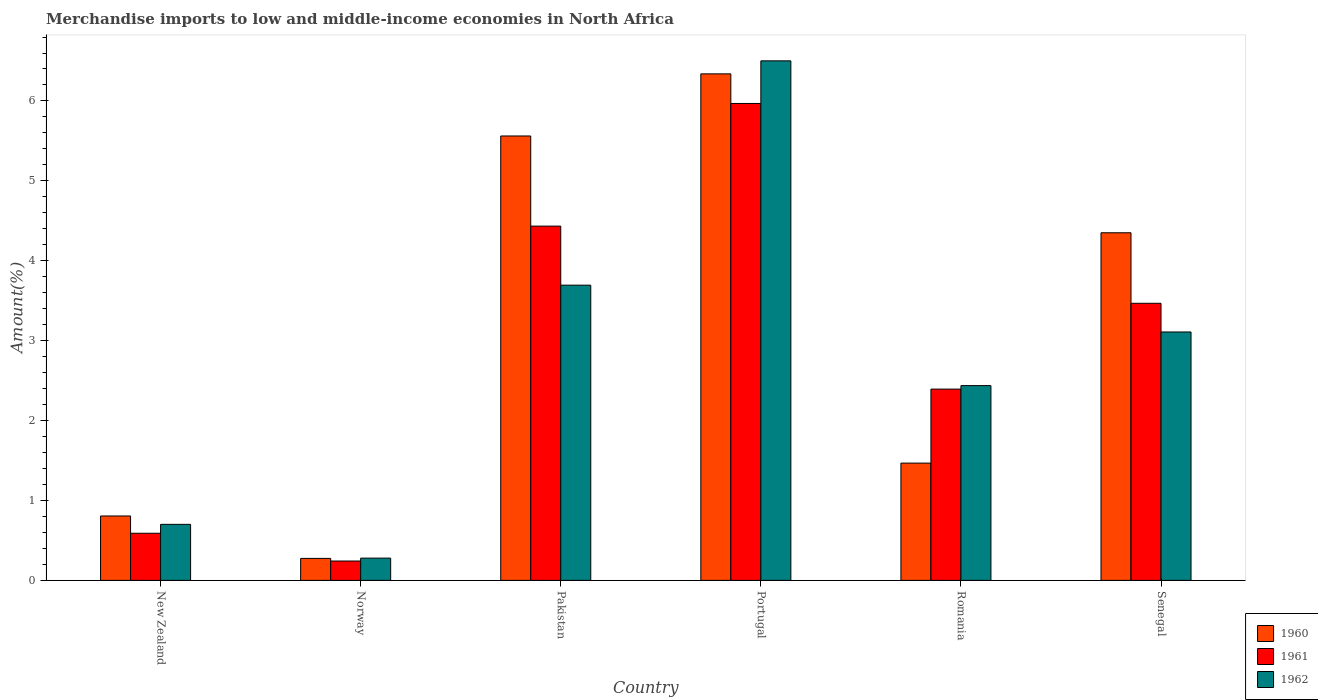How many different coloured bars are there?
Your response must be concise. 3. How many groups of bars are there?
Give a very brief answer. 6. Are the number of bars per tick equal to the number of legend labels?
Make the answer very short. Yes. Are the number of bars on each tick of the X-axis equal?
Ensure brevity in your answer.  Yes. What is the label of the 4th group of bars from the left?
Your response must be concise. Portugal. In how many cases, is the number of bars for a given country not equal to the number of legend labels?
Your response must be concise. 0. What is the percentage of amount earned from merchandise imports in 1961 in Pakistan?
Make the answer very short. 4.43. Across all countries, what is the maximum percentage of amount earned from merchandise imports in 1962?
Your response must be concise. 6.5. Across all countries, what is the minimum percentage of amount earned from merchandise imports in 1961?
Provide a succinct answer. 0.24. In which country was the percentage of amount earned from merchandise imports in 1961 maximum?
Offer a very short reply. Portugal. What is the total percentage of amount earned from merchandise imports in 1962 in the graph?
Offer a very short reply. 16.72. What is the difference between the percentage of amount earned from merchandise imports in 1961 in Pakistan and that in Senegal?
Provide a short and direct response. 0.97. What is the difference between the percentage of amount earned from merchandise imports in 1962 in Portugal and the percentage of amount earned from merchandise imports in 1961 in Pakistan?
Provide a short and direct response. 2.07. What is the average percentage of amount earned from merchandise imports in 1961 per country?
Your answer should be compact. 2.85. What is the difference between the percentage of amount earned from merchandise imports of/in 1961 and percentage of amount earned from merchandise imports of/in 1962 in New Zealand?
Keep it short and to the point. -0.11. What is the ratio of the percentage of amount earned from merchandise imports in 1960 in Pakistan to that in Portugal?
Provide a short and direct response. 0.88. What is the difference between the highest and the second highest percentage of amount earned from merchandise imports in 1962?
Offer a very short reply. -0.59. What is the difference between the highest and the lowest percentage of amount earned from merchandise imports in 1961?
Your answer should be very brief. 5.73. In how many countries, is the percentage of amount earned from merchandise imports in 1962 greater than the average percentage of amount earned from merchandise imports in 1962 taken over all countries?
Offer a very short reply. 3. Is the sum of the percentage of amount earned from merchandise imports in 1962 in Pakistan and Romania greater than the maximum percentage of amount earned from merchandise imports in 1961 across all countries?
Your response must be concise. Yes. What does the 2nd bar from the left in Senegal represents?
Your response must be concise. 1961. What does the 2nd bar from the right in Norway represents?
Your answer should be compact. 1961. Are the values on the major ticks of Y-axis written in scientific E-notation?
Provide a short and direct response. No. Does the graph contain grids?
Ensure brevity in your answer.  No. Where does the legend appear in the graph?
Provide a short and direct response. Bottom right. How many legend labels are there?
Your response must be concise. 3. What is the title of the graph?
Make the answer very short. Merchandise imports to low and middle-income economies in North Africa. Does "2011" appear as one of the legend labels in the graph?
Provide a succinct answer. No. What is the label or title of the X-axis?
Make the answer very short. Country. What is the label or title of the Y-axis?
Make the answer very short. Amount(%). What is the Amount(%) of 1960 in New Zealand?
Give a very brief answer. 0.81. What is the Amount(%) in 1961 in New Zealand?
Ensure brevity in your answer.  0.59. What is the Amount(%) in 1962 in New Zealand?
Provide a succinct answer. 0.7. What is the Amount(%) of 1960 in Norway?
Give a very brief answer. 0.28. What is the Amount(%) in 1961 in Norway?
Your answer should be compact. 0.24. What is the Amount(%) in 1962 in Norway?
Make the answer very short. 0.28. What is the Amount(%) in 1960 in Pakistan?
Your answer should be very brief. 5.56. What is the Amount(%) in 1961 in Pakistan?
Your answer should be compact. 4.43. What is the Amount(%) in 1962 in Pakistan?
Offer a very short reply. 3.69. What is the Amount(%) of 1960 in Portugal?
Your answer should be compact. 6.34. What is the Amount(%) in 1961 in Portugal?
Ensure brevity in your answer.  5.97. What is the Amount(%) in 1962 in Portugal?
Your answer should be compact. 6.5. What is the Amount(%) in 1960 in Romania?
Provide a short and direct response. 1.47. What is the Amount(%) in 1961 in Romania?
Offer a very short reply. 2.39. What is the Amount(%) in 1962 in Romania?
Your answer should be compact. 2.44. What is the Amount(%) of 1960 in Senegal?
Provide a succinct answer. 4.35. What is the Amount(%) of 1961 in Senegal?
Offer a very short reply. 3.47. What is the Amount(%) of 1962 in Senegal?
Your response must be concise. 3.11. Across all countries, what is the maximum Amount(%) of 1960?
Offer a terse response. 6.34. Across all countries, what is the maximum Amount(%) in 1961?
Offer a terse response. 5.97. Across all countries, what is the maximum Amount(%) in 1962?
Ensure brevity in your answer.  6.5. Across all countries, what is the minimum Amount(%) in 1960?
Your response must be concise. 0.28. Across all countries, what is the minimum Amount(%) of 1961?
Give a very brief answer. 0.24. Across all countries, what is the minimum Amount(%) of 1962?
Ensure brevity in your answer.  0.28. What is the total Amount(%) in 1960 in the graph?
Your response must be concise. 18.8. What is the total Amount(%) of 1961 in the graph?
Ensure brevity in your answer.  17.1. What is the total Amount(%) of 1962 in the graph?
Your answer should be very brief. 16.72. What is the difference between the Amount(%) of 1960 in New Zealand and that in Norway?
Keep it short and to the point. 0.53. What is the difference between the Amount(%) of 1961 in New Zealand and that in Norway?
Offer a very short reply. 0.35. What is the difference between the Amount(%) in 1962 in New Zealand and that in Norway?
Offer a terse response. 0.42. What is the difference between the Amount(%) of 1960 in New Zealand and that in Pakistan?
Ensure brevity in your answer.  -4.76. What is the difference between the Amount(%) of 1961 in New Zealand and that in Pakistan?
Offer a terse response. -3.84. What is the difference between the Amount(%) in 1962 in New Zealand and that in Pakistan?
Give a very brief answer. -2.99. What is the difference between the Amount(%) of 1960 in New Zealand and that in Portugal?
Make the answer very short. -5.53. What is the difference between the Amount(%) in 1961 in New Zealand and that in Portugal?
Provide a succinct answer. -5.38. What is the difference between the Amount(%) of 1962 in New Zealand and that in Portugal?
Offer a very short reply. -5.8. What is the difference between the Amount(%) of 1960 in New Zealand and that in Romania?
Make the answer very short. -0.66. What is the difference between the Amount(%) in 1961 in New Zealand and that in Romania?
Provide a short and direct response. -1.8. What is the difference between the Amount(%) in 1962 in New Zealand and that in Romania?
Make the answer very short. -1.74. What is the difference between the Amount(%) of 1960 in New Zealand and that in Senegal?
Your response must be concise. -3.54. What is the difference between the Amount(%) of 1961 in New Zealand and that in Senegal?
Ensure brevity in your answer.  -2.88. What is the difference between the Amount(%) of 1962 in New Zealand and that in Senegal?
Provide a succinct answer. -2.41. What is the difference between the Amount(%) of 1960 in Norway and that in Pakistan?
Ensure brevity in your answer.  -5.29. What is the difference between the Amount(%) in 1961 in Norway and that in Pakistan?
Provide a succinct answer. -4.19. What is the difference between the Amount(%) of 1962 in Norway and that in Pakistan?
Keep it short and to the point. -3.42. What is the difference between the Amount(%) in 1960 in Norway and that in Portugal?
Provide a short and direct response. -6.06. What is the difference between the Amount(%) of 1961 in Norway and that in Portugal?
Ensure brevity in your answer.  -5.73. What is the difference between the Amount(%) of 1962 in Norway and that in Portugal?
Give a very brief answer. -6.22. What is the difference between the Amount(%) of 1960 in Norway and that in Romania?
Keep it short and to the point. -1.19. What is the difference between the Amount(%) of 1961 in Norway and that in Romania?
Provide a succinct answer. -2.15. What is the difference between the Amount(%) of 1962 in Norway and that in Romania?
Your answer should be very brief. -2.16. What is the difference between the Amount(%) of 1960 in Norway and that in Senegal?
Keep it short and to the point. -4.08. What is the difference between the Amount(%) in 1961 in Norway and that in Senegal?
Give a very brief answer. -3.23. What is the difference between the Amount(%) in 1962 in Norway and that in Senegal?
Your answer should be very brief. -2.83. What is the difference between the Amount(%) of 1960 in Pakistan and that in Portugal?
Make the answer very short. -0.78. What is the difference between the Amount(%) of 1961 in Pakistan and that in Portugal?
Ensure brevity in your answer.  -1.54. What is the difference between the Amount(%) in 1962 in Pakistan and that in Portugal?
Your answer should be very brief. -2.81. What is the difference between the Amount(%) of 1960 in Pakistan and that in Romania?
Your answer should be compact. 4.09. What is the difference between the Amount(%) of 1961 in Pakistan and that in Romania?
Provide a succinct answer. 2.04. What is the difference between the Amount(%) of 1962 in Pakistan and that in Romania?
Keep it short and to the point. 1.26. What is the difference between the Amount(%) of 1960 in Pakistan and that in Senegal?
Your answer should be compact. 1.21. What is the difference between the Amount(%) of 1961 in Pakistan and that in Senegal?
Offer a terse response. 0.97. What is the difference between the Amount(%) in 1962 in Pakistan and that in Senegal?
Your answer should be very brief. 0.59. What is the difference between the Amount(%) of 1960 in Portugal and that in Romania?
Offer a very short reply. 4.87. What is the difference between the Amount(%) in 1961 in Portugal and that in Romania?
Your response must be concise. 3.57. What is the difference between the Amount(%) in 1962 in Portugal and that in Romania?
Give a very brief answer. 4.06. What is the difference between the Amount(%) in 1960 in Portugal and that in Senegal?
Your answer should be very brief. 1.99. What is the difference between the Amount(%) of 1961 in Portugal and that in Senegal?
Offer a terse response. 2.5. What is the difference between the Amount(%) in 1962 in Portugal and that in Senegal?
Give a very brief answer. 3.39. What is the difference between the Amount(%) of 1960 in Romania and that in Senegal?
Provide a short and direct response. -2.88. What is the difference between the Amount(%) in 1961 in Romania and that in Senegal?
Ensure brevity in your answer.  -1.07. What is the difference between the Amount(%) in 1962 in Romania and that in Senegal?
Give a very brief answer. -0.67. What is the difference between the Amount(%) in 1960 in New Zealand and the Amount(%) in 1961 in Norway?
Keep it short and to the point. 0.56. What is the difference between the Amount(%) in 1960 in New Zealand and the Amount(%) in 1962 in Norway?
Your answer should be very brief. 0.53. What is the difference between the Amount(%) in 1961 in New Zealand and the Amount(%) in 1962 in Norway?
Your answer should be compact. 0.31. What is the difference between the Amount(%) of 1960 in New Zealand and the Amount(%) of 1961 in Pakistan?
Your response must be concise. -3.63. What is the difference between the Amount(%) of 1960 in New Zealand and the Amount(%) of 1962 in Pakistan?
Offer a terse response. -2.89. What is the difference between the Amount(%) of 1961 in New Zealand and the Amount(%) of 1962 in Pakistan?
Your answer should be very brief. -3.1. What is the difference between the Amount(%) of 1960 in New Zealand and the Amount(%) of 1961 in Portugal?
Provide a short and direct response. -5.16. What is the difference between the Amount(%) of 1960 in New Zealand and the Amount(%) of 1962 in Portugal?
Provide a short and direct response. -5.7. What is the difference between the Amount(%) of 1961 in New Zealand and the Amount(%) of 1962 in Portugal?
Ensure brevity in your answer.  -5.91. What is the difference between the Amount(%) in 1960 in New Zealand and the Amount(%) in 1961 in Romania?
Your answer should be very brief. -1.59. What is the difference between the Amount(%) of 1960 in New Zealand and the Amount(%) of 1962 in Romania?
Provide a short and direct response. -1.63. What is the difference between the Amount(%) of 1961 in New Zealand and the Amount(%) of 1962 in Romania?
Offer a terse response. -1.85. What is the difference between the Amount(%) in 1960 in New Zealand and the Amount(%) in 1961 in Senegal?
Your answer should be very brief. -2.66. What is the difference between the Amount(%) of 1960 in New Zealand and the Amount(%) of 1962 in Senegal?
Give a very brief answer. -2.3. What is the difference between the Amount(%) of 1961 in New Zealand and the Amount(%) of 1962 in Senegal?
Ensure brevity in your answer.  -2.52. What is the difference between the Amount(%) in 1960 in Norway and the Amount(%) in 1961 in Pakistan?
Ensure brevity in your answer.  -4.16. What is the difference between the Amount(%) of 1960 in Norway and the Amount(%) of 1962 in Pakistan?
Your answer should be very brief. -3.42. What is the difference between the Amount(%) of 1961 in Norway and the Amount(%) of 1962 in Pakistan?
Offer a terse response. -3.45. What is the difference between the Amount(%) in 1960 in Norway and the Amount(%) in 1961 in Portugal?
Ensure brevity in your answer.  -5.69. What is the difference between the Amount(%) of 1960 in Norway and the Amount(%) of 1962 in Portugal?
Offer a terse response. -6.23. What is the difference between the Amount(%) in 1961 in Norway and the Amount(%) in 1962 in Portugal?
Offer a very short reply. -6.26. What is the difference between the Amount(%) in 1960 in Norway and the Amount(%) in 1961 in Romania?
Make the answer very short. -2.12. What is the difference between the Amount(%) of 1960 in Norway and the Amount(%) of 1962 in Romania?
Your answer should be very brief. -2.16. What is the difference between the Amount(%) of 1961 in Norway and the Amount(%) of 1962 in Romania?
Make the answer very short. -2.2. What is the difference between the Amount(%) of 1960 in Norway and the Amount(%) of 1961 in Senegal?
Offer a terse response. -3.19. What is the difference between the Amount(%) of 1960 in Norway and the Amount(%) of 1962 in Senegal?
Ensure brevity in your answer.  -2.83. What is the difference between the Amount(%) of 1961 in Norway and the Amount(%) of 1962 in Senegal?
Your answer should be compact. -2.87. What is the difference between the Amount(%) of 1960 in Pakistan and the Amount(%) of 1961 in Portugal?
Provide a succinct answer. -0.41. What is the difference between the Amount(%) in 1960 in Pakistan and the Amount(%) in 1962 in Portugal?
Offer a very short reply. -0.94. What is the difference between the Amount(%) in 1961 in Pakistan and the Amount(%) in 1962 in Portugal?
Make the answer very short. -2.07. What is the difference between the Amount(%) in 1960 in Pakistan and the Amount(%) in 1961 in Romania?
Ensure brevity in your answer.  3.17. What is the difference between the Amount(%) in 1960 in Pakistan and the Amount(%) in 1962 in Romania?
Your answer should be very brief. 3.12. What is the difference between the Amount(%) in 1961 in Pakistan and the Amount(%) in 1962 in Romania?
Your answer should be very brief. 2. What is the difference between the Amount(%) in 1960 in Pakistan and the Amount(%) in 1961 in Senegal?
Your answer should be very brief. 2.09. What is the difference between the Amount(%) of 1960 in Pakistan and the Amount(%) of 1962 in Senegal?
Provide a short and direct response. 2.45. What is the difference between the Amount(%) of 1961 in Pakistan and the Amount(%) of 1962 in Senegal?
Ensure brevity in your answer.  1.32. What is the difference between the Amount(%) of 1960 in Portugal and the Amount(%) of 1961 in Romania?
Keep it short and to the point. 3.94. What is the difference between the Amount(%) of 1960 in Portugal and the Amount(%) of 1962 in Romania?
Provide a succinct answer. 3.9. What is the difference between the Amount(%) in 1961 in Portugal and the Amount(%) in 1962 in Romania?
Provide a succinct answer. 3.53. What is the difference between the Amount(%) of 1960 in Portugal and the Amount(%) of 1961 in Senegal?
Provide a short and direct response. 2.87. What is the difference between the Amount(%) of 1960 in Portugal and the Amount(%) of 1962 in Senegal?
Offer a very short reply. 3.23. What is the difference between the Amount(%) in 1961 in Portugal and the Amount(%) in 1962 in Senegal?
Offer a terse response. 2.86. What is the difference between the Amount(%) in 1960 in Romania and the Amount(%) in 1961 in Senegal?
Provide a short and direct response. -2. What is the difference between the Amount(%) of 1960 in Romania and the Amount(%) of 1962 in Senegal?
Your response must be concise. -1.64. What is the difference between the Amount(%) of 1961 in Romania and the Amount(%) of 1962 in Senegal?
Provide a short and direct response. -0.71. What is the average Amount(%) in 1960 per country?
Offer a terse response. 3.13. What is the average Amount(%) of 1961 per country?
Offer a terse response. 2.85. What is the average Amount(%) in 1962 per country?
Ensure brevity in your answer.  2.79. What is the difference between the Amount(%) in 1960 and Amount(%) in 1961 in New Zealand?
Keep it short and to the point. 0.22. What is the difference between the Amount(%) of 1960 and Amount(%) of 1962 in New Zealand?
Make the answer very short. 0.1. What is the difference between the Amount(%) in 1961 and Amount(%) in 1962 in New Zealand?
Your response must be concise. -0.11. What is the difference between the Amount(%) of 1960 and Amount(%) of 1961 in Norway?
Your response must be concise. 0.03. What is the difference between the Amount(%) in 1960 and Amount(%) in 1962 in Norway?
Provide a succinct answer. -0. What is the difference between the Amount(%) in 1961 and Amount(%) in 1962 in Norway?
Your response must be concise. -0.04. What is the difference between the Amount(%) in 1960 and Amount(%) in 1961 in Pakistan?
Offer a very short reply. 1.13. What is the difference between the Amount(%) in 1960 and Amount(%) in 1962 in Pakistan?
Your answer should be compact. 1.87. What is the difference between the Amount(%) of 1961 and Amount(%) of 1962 in Pakistan?
Give a very brief answer. 0.74. What is the difference between the Amount(%) in 1960 and Amount(%) in 1961 in Portugal?
Your answer should be very brief. 0.37. What is the difference between the Amount(%) in 1960 and Amount(%) in 1962 in Portugal?
Keep it short and to the point. -0.16. What is the difference between the Amount(%) of 1961 and Amount(%) of 1962 in Portugal?
Give a very brief answer. -0.53. What is the difference between the Amount(%) of 1960 and Amount(%) of 1961 in Romania?
Your answer should be compact. -0.93. What is the difference between the Amount(%) of 1960 and Amount(%) of 1962 in Romania?
Your answer should be very brief. -0.97. What is the difference between the Amount(%) of 1961 and Amount(%) of 1962 in Romania?
Offer a terse response. -0.04. What is the difference between the Amount(%) of 1960 and Amount(%) of 1961 in Senegal?
Give a very brief answer. 0.88. What is the difference between the Amount(%) of 1960 and Amount(%) of 1962 in Senegal?
Your answer should be compact. 1.24. What is the difference between the Amount(%) in 1961 and Amount(%) in 1962 in Senegal?
Make the answer very short. 0.36. What is the ratio of the Amount(%) of 1960 in New Zealand to that in Norway?
Give a very brief answer. 2.93. What is the ratio of the Amount(%) of 1961 in New Zealand to that in Norway?
Offer a very short reply. 2.43. What is the ratio of the Amount(%) in 1962 in New Zealand to that in Norway?
Ensure brevity in your answer.  2.52. What is the ratio of the Amount(%) of 1960 in New Zealand to that in Pakistan?
Give a very brief answer. 0.14. What is the ratio of the Amount(%) of 1961 in New Zealand to that in Pakistan?
Make the answer very short. 0.13. What is the ratio of the Amount(%) in 1962 in New Zealand to that in Pakistan?
Keep it short and to the point. 0.19. What is the ratio of the Amount(%) in 1960 in New Zealand to that in Portugal?
Give a very brief answer. 0.13. What is the ratio of the Amount(%) in 1961 in New Zealand to that in Portugal?
Offer a very short reply. 0.1. What is the ratio of the Amount(%) of 1962 in New Zealand to that in Portugal?
Offer a terse response. 0.11. What is the ratio of the Amount(%) of 1960 in New Zealand to that in Romania?
Provide a succinct answer. 0.55. What is the ratio of the Amount(%) in 1961 in New Zealand to that in Romania?
Your answer should be compact. 0.25. What is the ratio of the Amount(%) in 1962 in New Zealand to that in Romania?
Your response must be concise. 0.29. What is the ratio of the Amount(%) in 1960 in New Zealand to that in Senegal?
Your answer should be compact. 0.19. What is the ratio of the Amount(%) in 1961 in New Zealand to that in Senegal?
Your response must be concise. 0.17. What is the ratio of the Amount(%) of 1962 in New Zealand to that in Senegal?
Keep it short and to the point. 0.23. What is the ratio of the Amount(%) in 1960 in Norway to that in Pakistan?
Your answer should be compact. 0.05. What is the ratio of the Amount(%) of 1961 in Norway to that in Pakistan?
Make the answer very short. 0.05. What is the ratio of the Amount(%) of 1962 in Norway to that in Pakistan?
Give a very brief answer. 0.08. What is the ratio of the Amount(%) of 1960 in Norway to that in Portugal?
Provide a short and direct response. 0.04. What is the ratio of the Amount(%) in 1961 in Norway to that in Portugal?
Your answer should be compact. 0.04. What is the ratio of the Amount(%) in 1962 in Norway to that in Portugal?
Offer a very short reply. 0.04. What is the ratio of the Amount(%) of 1960 in Norway to that in Romania?
Provide a succinct answer. 0.19. What is the ratio of the Amount(%) in 1961 in Norway to that in Romania?
Your response must be concise. 0.1. What is the ratio of the Amount(%) in 1962 in Norway to that in Romania?
Keep it short and to the point. 0.11. What is the ratio of the Amount(%) in 1960 in Norway to that in Senegal?
Ensure brevity in your answer.  0.06. What is the ratio of the Amount(%) of 1961 in Norway to that in Senegal?
Offer a very short reply. 0.07. What is the ratio of the Amount(%) in 1962 in Norway to that in Senegal?
Your answer should be compact. 0.09. What is the ratio of the Amount(%) in 1960 in Pakistan to that in Portugal?
Provide a short and direct response. 0.88. What is the ratio of the Amount(%) in 1961 in Pakistan to that in Portugal?
Keep it short and to the point. 0.74. What is the ratio of the Amount(%) of 1962 in Pakistan to that in Portugal?
Your response must be concise. 0.57. What is the ratio of the Amount(%) of 1960 in Pakistan to that in Romania?
Give a very brief answer. 3.79. What is the ratio of the Amount(%) of 1961 in Pakistan to that in Romania?
Keep it short and to the point. 1.85. What is the ratio of the Amount(%) of 1962 in Pakistan to that in Romania?
Provide a succinct answer. 1.52. What is the ratio of the Amount(%) of 1960 in Pakistan to that in Senegal?
Provide a short and direct response. 1.28. What is the ratio of the Amount(%) in 1961 in Pakistan to that in Senegal?
Your answer should be very brief. 1.28. What is the ratio of the Amount(%) of 1962 in Pakistan to that in Senegal?
Offer a very short reply. 1.19. What is the ratio of the Amount(%) of 1960 in Portugal to that in Romania?
Your response must be concise. 4.32. What is the ratio of the Amount(%) of 1961 in Portugal to that in Romania?
Keep it short and to the point. 2.49. What is the ratio of the Amount(%) in 1962 in Portugal to that in Romania?
Ensure brevity in your answer.  2.67. What is the ratio of the Amount(%) of 1960 in Portugal to that in Senegal?
Keep it short and to the point. 1.46. What is the ratio of the Amount(%) in 1961 in Portugal to that in Senegal?
Your answer should be compact. 1.72. What is the ratio of the Amount(%) in 1962 in Portugal to that in Senegal?
Provide a succinct answer. 2.09. What is the ratio of the Amount(%) in 1960 in Romania to that in Senegal?
Keep it short and to the point. 0.34. What is the ratio of the Amount(%) of 1961 in Romania to that in Senegal?
Provide a succinct answer. 0.69. What is the ratio of the Amount(%) of 1962 in Romania to that in Senegal?
Provide a short and direct response. 0.78. What is the difference between the highest and the second highest Amount(%) of 1960?
Keep it short and to the point. 0.78. What is the difference between the highest and the second highest Amount(%) in 1961?
Give a very brief answer. 1.54. What is the difference between the highest and the second highest Amount(%) of 1962?
Your response must be concise. 2.81. What is the difference between the highest and the lowest Amount(%) in 1960?
Your answer should be compact. 6.06. What is the difference between the highest and the lowest Amount(%) in 1961?
Offer a very short reply. 5.73. What is the difference between the highest and the lowest Amount(%) in 1962?
Your answer should be compact. 6.22. 